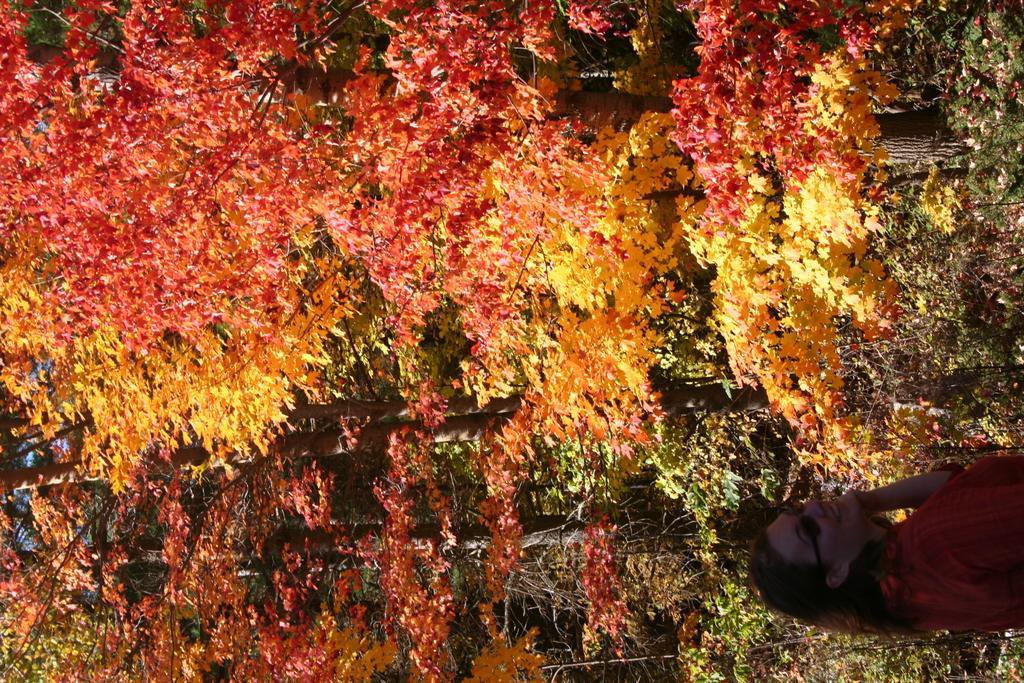How would you summarize this image in a sentence or two? In this picture I can see trees and a woman standing and she wore spectacles. 